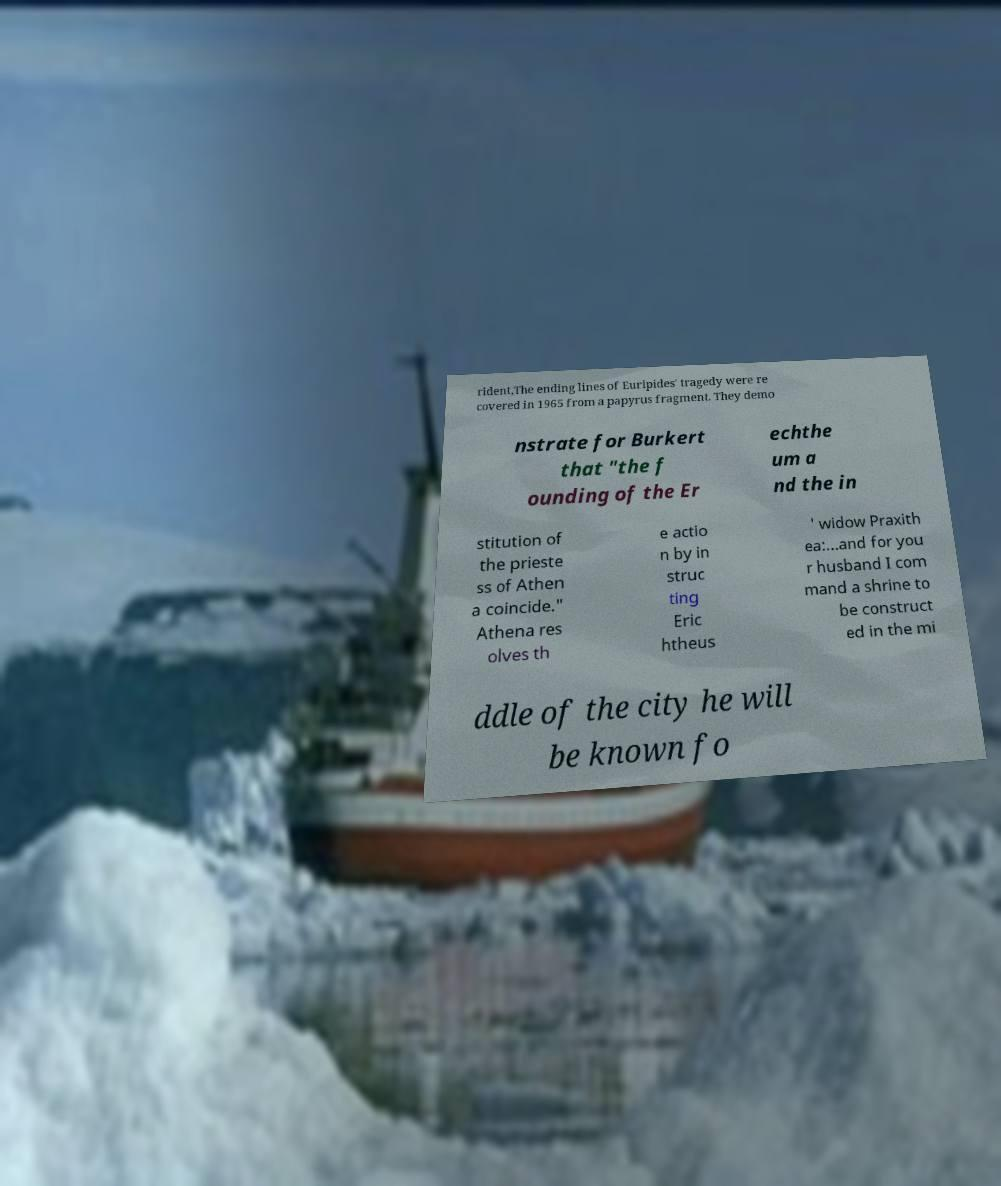Could you assist in decoding the text presented in this image and type it out clearly? rident,The ending lines of Euripides' tragedy were re covered in 1965 from a papyrus fragment. They demo nstrate for Burkert that "the f ounding of the Er echthe um a nd the in stitution of the prieste ss of Athen a coincide." Athena res olves th e actio n by in struc ting Eric htheus ' widow Praxith ea:...and for you r husband I com mand a shrine to be construct ed in the mi ddle of the city he will be known fo 